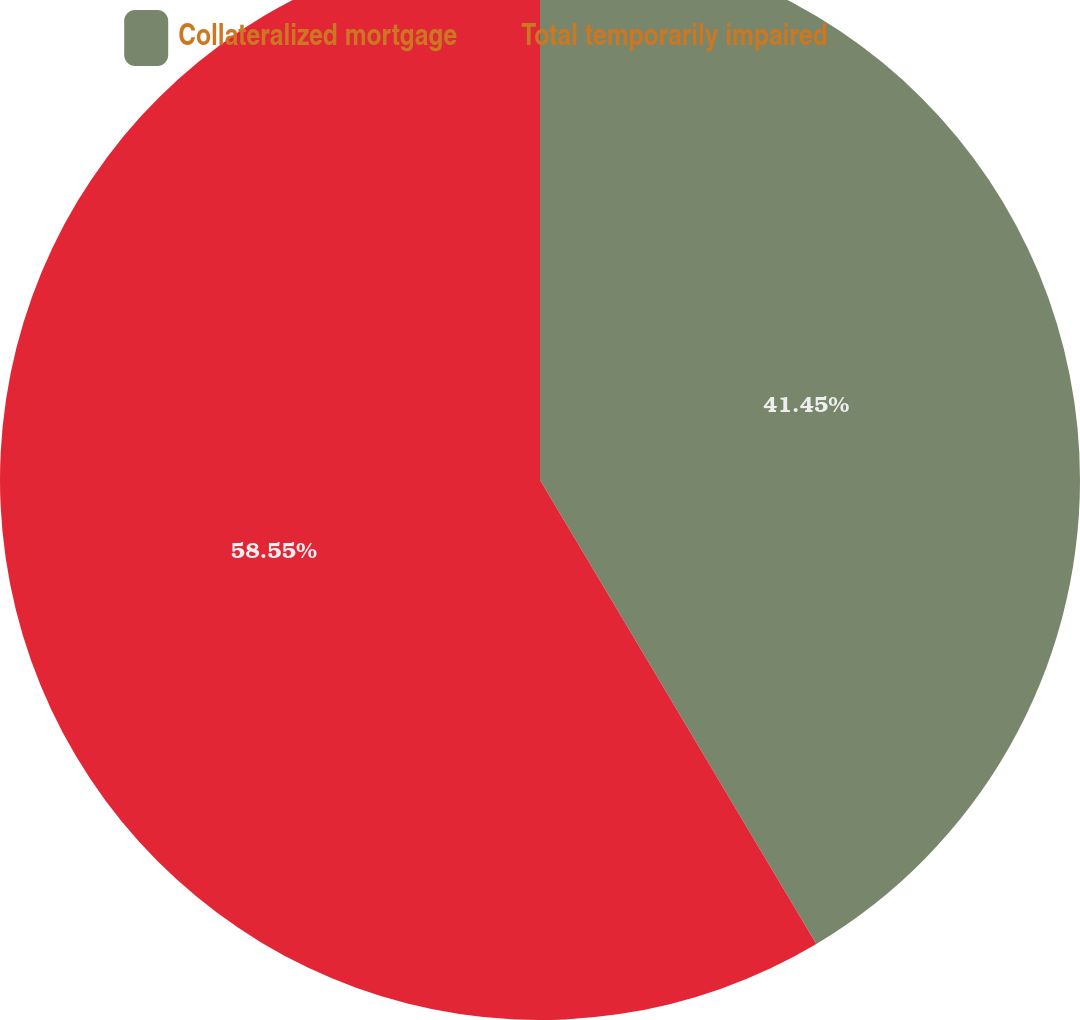<chart> <loc_0><loc_0><loc_500><loc_500><pie_chart><fcel>Collateralized mortgage<fcel>Total temporarily impaired<nl><fcel>41.45%<fcel>58.55%<nl></chart> 